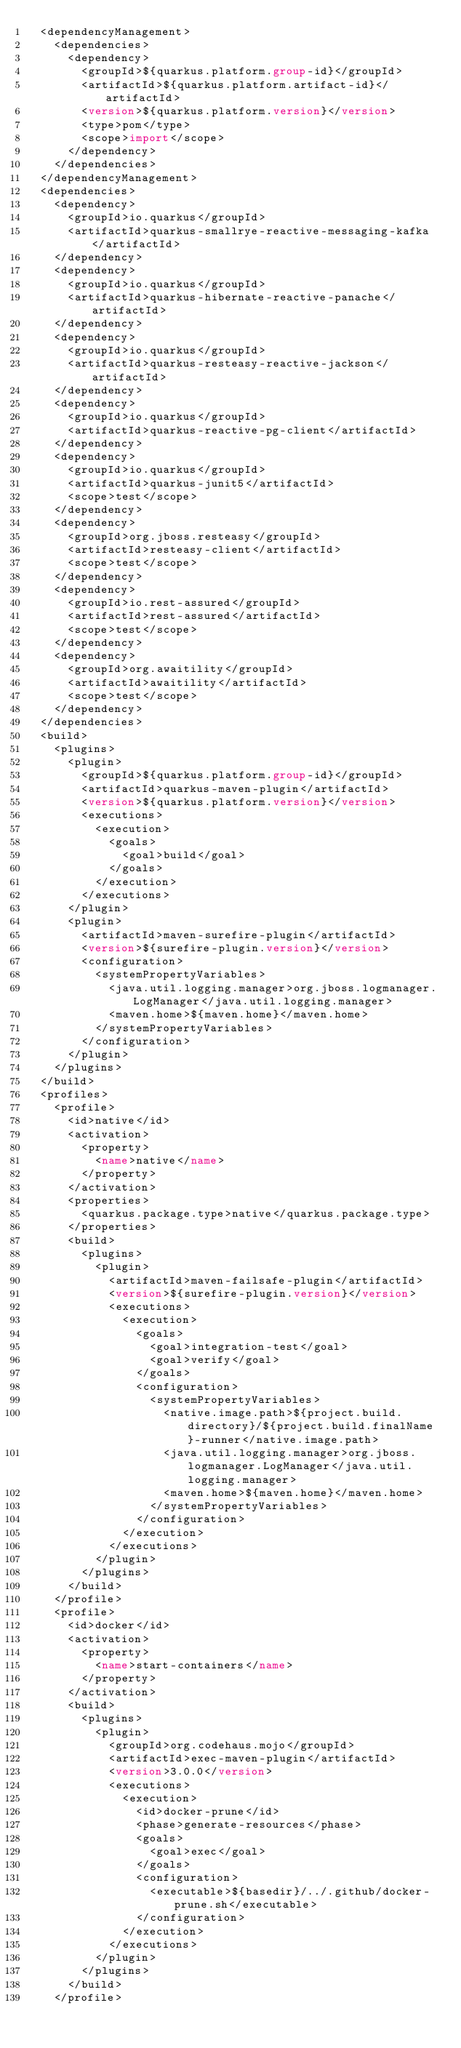<code> <loc_0><loc_0><loc_500><loc_500><_XML_>  <dependencyManagement>
    <dependencies>
      <dependency>
        <groupId>${quarkus.platform.group-id}</groupId>
        <artifactId>${quarkus.platform.artifact-id}</artifactId>
        <version>${quarkus.platform.version}</version>
        <type>pom</type>
        <scope>import</scope>
      </dependency>
    </dependencies>
  </dependencyManagement>
  <dependencies>
    <dependency>
      <groupId>io.quarkus</groupId>
      <artifactId>quarkus-smallrye-reactive-messaging-kafka</artifactId>
    </dependency>
    <dependency>
      <groupId>io.quarkus</groupId>
      <artifactId>quarkus-hibernate-reactive-panache</artifactId>
    </dependency>
    <dependency>
      <groupId>io.quarkus</groupId>
      <artifactId>quarkus-resteasy-reactive-jackson</artifactId>
    </dependency>
    <dependency>
      <groupId>io.quarkus</groupId>
      <artifactId>quarkus-reactive-pg-client</artifactId>
    </dependency>
    <dependency>
      <groupId>io.quarkus</groupId>
      <artifactId>quarkus-junit5</artifactId>
      <scope>test</scope>
    </dependency>
    <dependency>
      <groupId>org.jboss.resteasy</groupId>
      <artifactId>resteasy-client</artifactId>
      <scope>test</scope>
    </dependency>
    <dependency>
      <groupId>io.rest-assured</groupId>
      <artifactId>rest-assured</artifactId>
      <scope>test</scope>
    </dependency>
    <dependency>
      <groupId>org.awaitility</groupId>
      <artifactId>awaitility</artifactId>
      <scope>test</scope>
    </dependency>
  </dependencies>
  <build>
    <plugins>
      <plugin>
        <groupId>${quarkus.platform.group-id}</groupId>
        <artifactId>quarkus-maven-plugin</artifactId>
        <version>${quarkus.platform.version}</version>
        <executions>
          <execution>
            <goals>
              <goal>build</goal>
            </goals>
          </execution>
        </executions>
      </plugin>
      <plugin>
        <artifactId>maven-surefire-plugin</artifactId>
        <version>${surefire-plugin.version}</version>
        <configuration>
          <systemPropertyVariables>
            <java.util.logging.manager>org.jboss.logmanager.LogManager</java.util.logging.manager>
            <maven.home>${maven.home}</maven.home>
          </systemPropertyVariables>
        </configuration>
      </plugin>
    </plugins>
  </build>
  <profiles>
    <profile>
      <id>native</id>
      <activation>
        <property>
          <name>native</name>
        </property>
      </activation>
      <properties>
        <quarkus.package.type>native</quarkus.package.type>
      </properties>
      <build>
        <plugins>
          <plugin>
            <artifactId>maven-failsafe-plugin</artifactId>
            <version>${surefire-plugin.version}</version>
            <executions>
              <execution>
                <goals>
                  <goal>integration-test</goal>
                  <goal>verify</goal>
                </goals>
                <configuration>
                  <systemPropertyVariables>
                    <native.image.path>${project.build.directory}/${project.build.finalName}-runner</native.image.path>
                    <java.util.logging.manager>org.jboss.logmanager.LogManager</java.util.logging.manager>
                    <maven.home>${maven.home}</maven.home>
                  </systemPropertyVariables>
                </configuration>
              </execution>
            </executions>
          </plugin>
        </plugins>
      </build>
    </profile>
    <profile>
      <id>docker</id>
      <activation>
        <property>
          <name>start-containers</name>
        </property>
      </activation>
      <build>
        <plugins>
          <plugin>
            <groupId>org.codehaus.mojo</groupId>
            <artifactId>exec-maven-plugin</artifactId>
            <version>3.0.0</version>
            <executions>
              <execution>
                <id>docker-prune</id>
                <phase>generate-resources</phase>
                <goals>
                  <goal>exec</goal>
                </goals>
                <configuration>
                  <executable>${basedir}/../.github/docker-prune.sh</executable>
                </configuration>
              </execution>
            </executions>
          </plugin>
        </plugins>
      </build>
    </profile></code> 